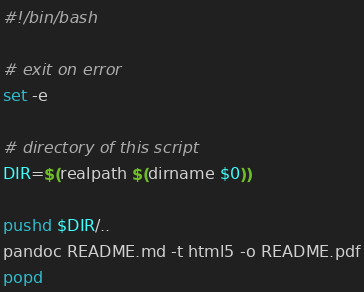Convert code to text. <code><loc_0><loc_0><loc_500><loc_500><_Bash_>#!/bin/bash

# exit on error
set -e

# directory of this script
DIR=$(realpath $(dirname $0))

pushd $DIR/..
pandoc README.md -t html5 -o README.pdf
popd</code> 